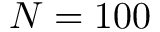Convert formula to latex. <formula><loc_0><loc_0><loc_500><loc_500>N = 1 0 0</formula> 